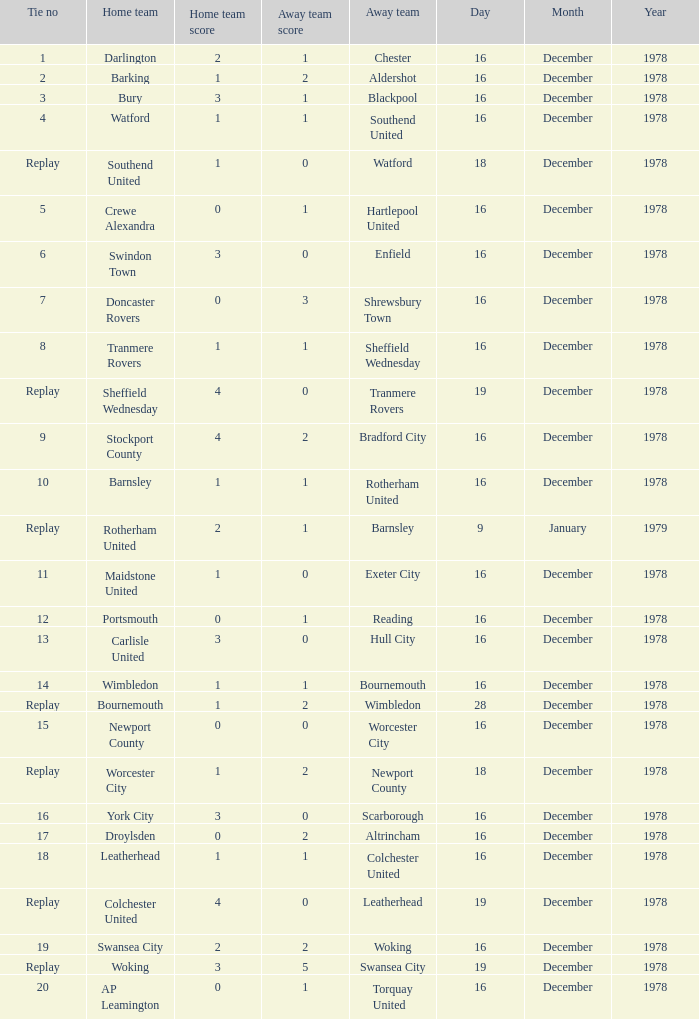What date had a tie no of replay, and an away team of watford? 18 December 1978. 